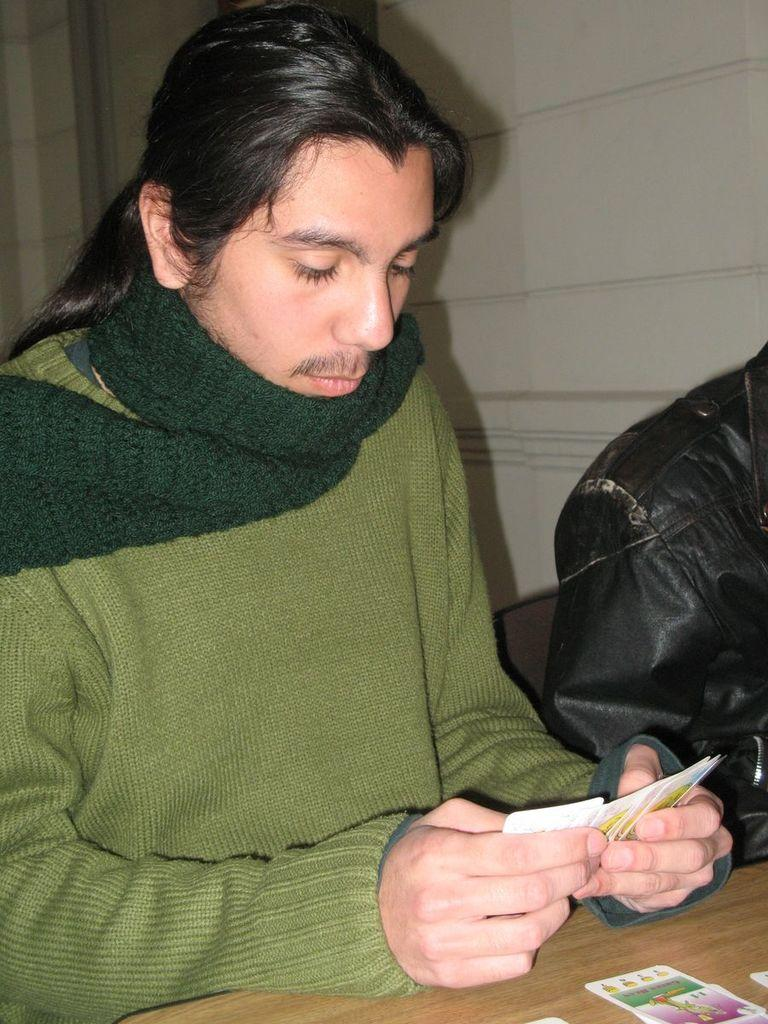What are the people in the image doing? The people in the image are seated. What is the man holding in his hands? The man is holding cards in his hands. Are there any cards visible on the table? Yes, there are cards on the table. What accessory is the man wearing around his neck? The man has a scarf around his neck. What type of nail is the man using to play the cards in the image? There is no nail visible in the image, and the man is not using any tool to play the cards. 